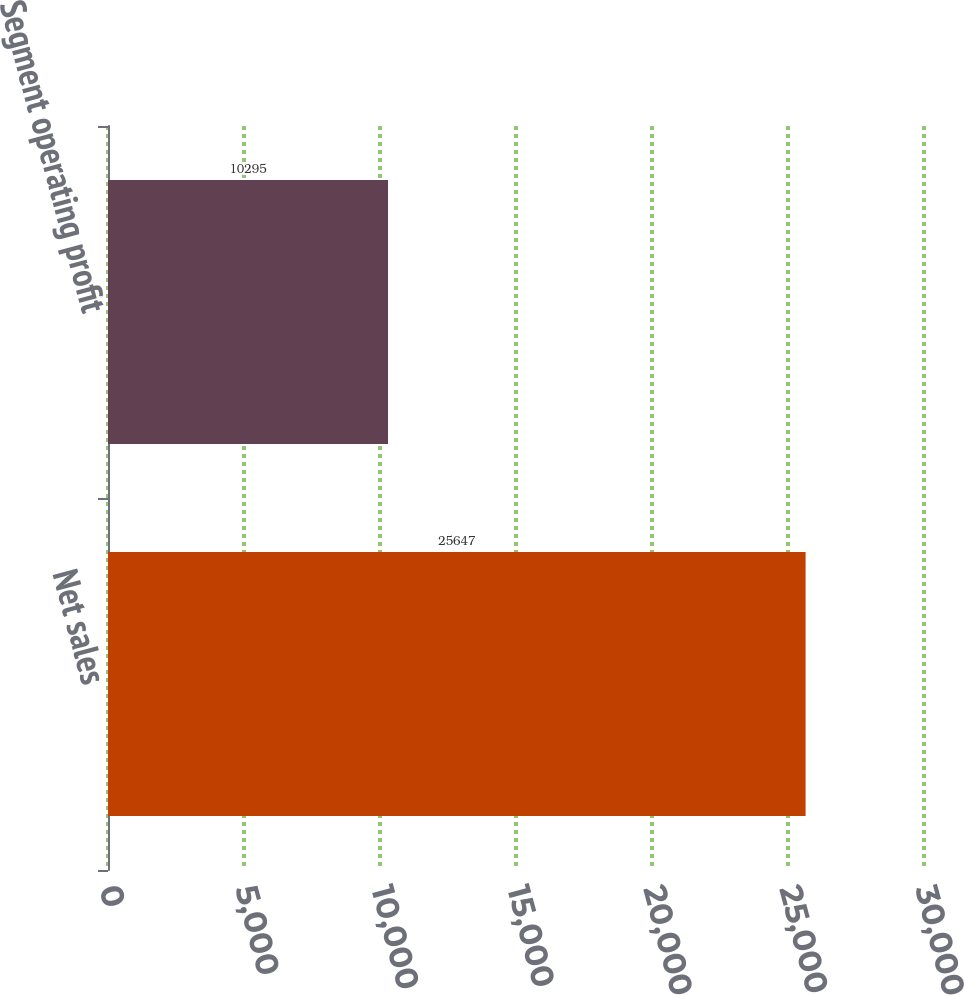Convert chart. <chart><loc_0><loc_0><loc_500><loc_500><bar_chart><fcel>Net sales<fcel>Segment operating profit<nl><fcel>25647<fcel>10295<nl></chart> 